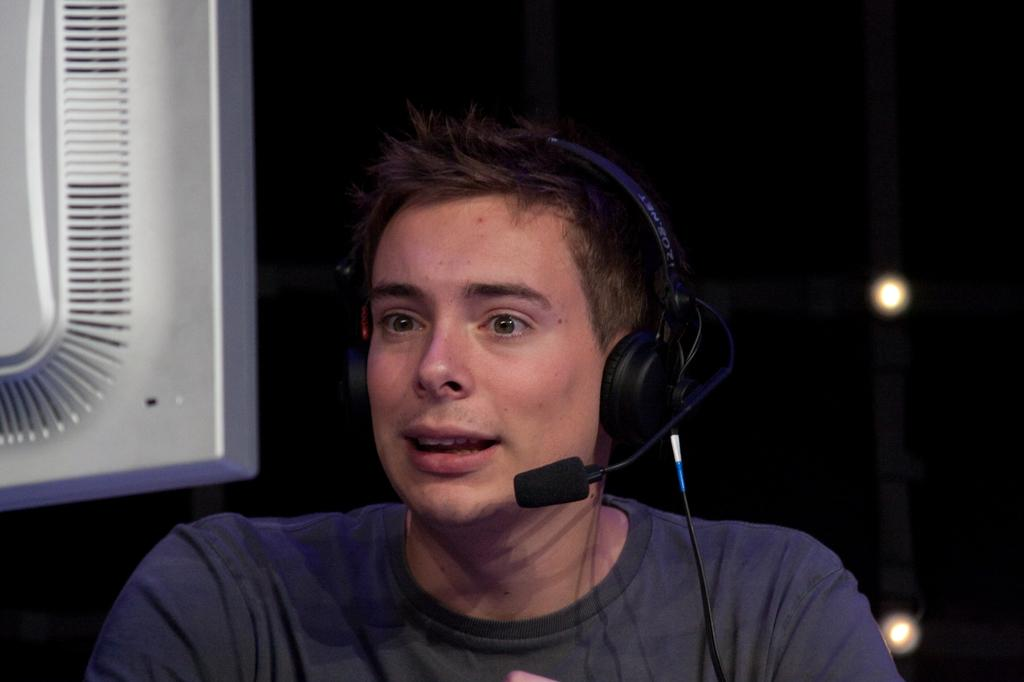Who is present in the image? There is a man in the image. What is the man wearing on his head? The man is wearing a headset. What is in front of the man? There is a monitor in front of some distance away from the man. What can be seen in the background of the image? There are lights visible in the background of the image. What type of scissors can be seen cutting the level in the image? There is no level or scissors present in the image; it features a man wearing a headset and a monitor in front of him. 